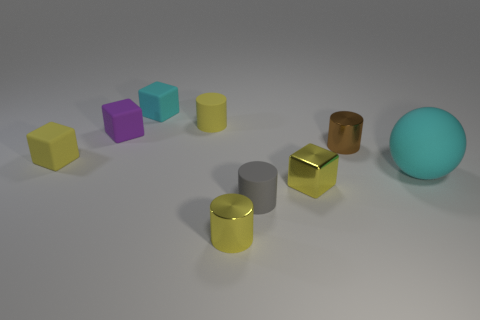Subtract 1 cylinders. How many cylinders are left? 3 Add 1 large things. How many objects exist? 10 Subtract all cubes. How many objects are left? 5 Subtract 0 gray balls. How many objects are left? 9 Subtract all balls. Subtract all small things. How many objects are left? 0 Add 6 small yellow cylinders. How many small yellow cylinders are left? 8 Add 2 tiny yellow metallic cylinders. How many tiny yellow metallic cylinders exist? 3 